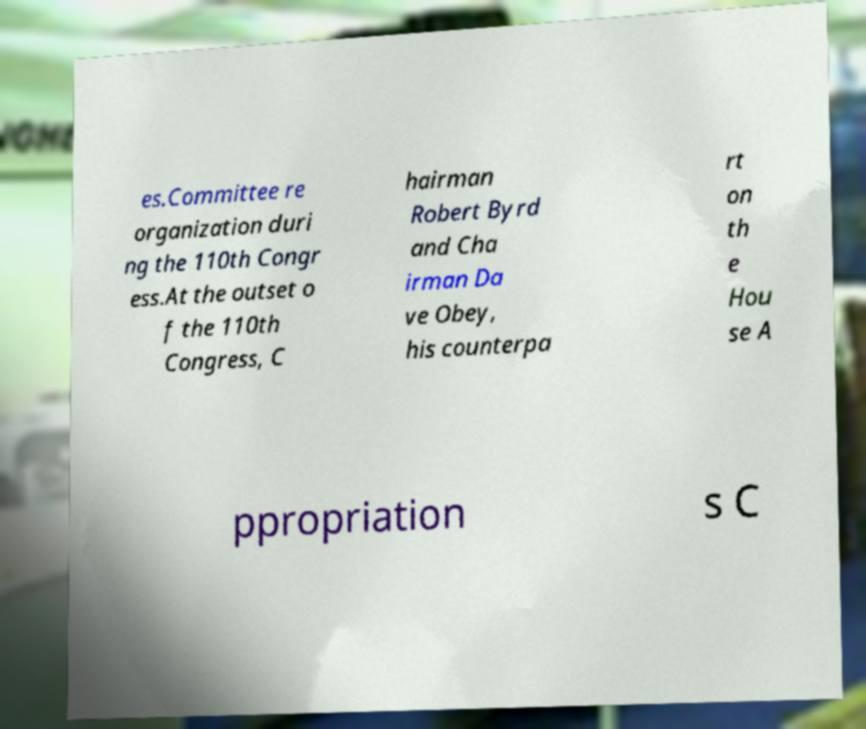Can you read and provide the text displayed in the image?This photo seems to have some interesting text. Can you extract and type it out for me? es.Committee re organization duri ng the 110th Congr ess.At the outset o f the 110th Congress, C hairman Robert Byrd and Cha irman Da ve Obey, his counterpa rt on th e Hou se A ppropriation s C 